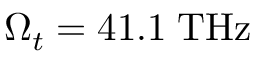<formula> <loc_0><loc_0><loc_500><loc_500>\Omega _ { t } = 4 1 . 1 \, T H z</formula> 